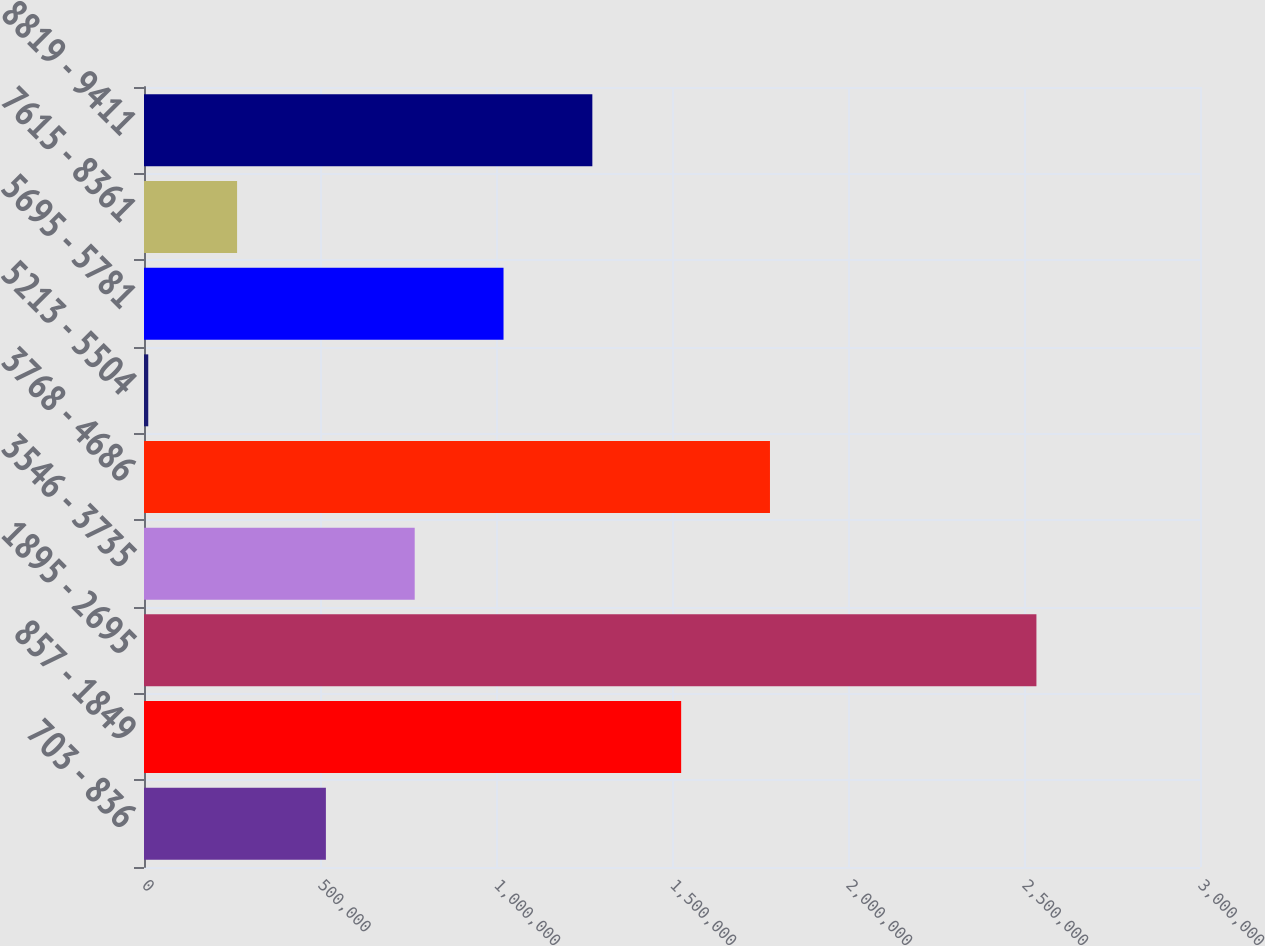Convert chart to OTSL. <chart><loc_0><loc_0><loc_500><loc_500><bar_chart><fcel>703 - 836<fcel>857 - 1849<fcel>1895 - 2695<fcel>3546 - 3735<fcel>3768 - 4686<fcel>5213 - 5504<fcel>5695 - 5781<fcel>7615 - 8361<fcel>8819 - 9411<nl><fcel>516737<fcel>1.52601e+06<fcel>2.53529e+06<fcel>769056<fcel>1.77833e+06<fcel>12100<fcel>1.02137e+06<fcel>264419<fcel>1.27369e+06<nl></chart> 